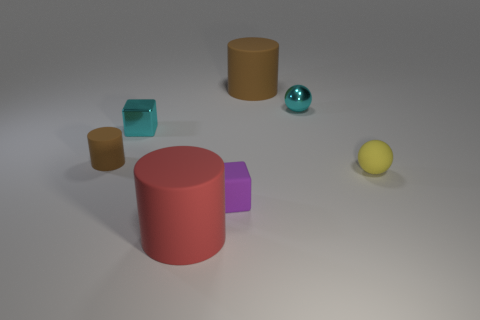How would you categorize the arrangement of objects in the image? The objects are arranged in a somewhat scattered fashion across a flat surface but maintain a sense of balance and simplicity. It appears to be a deliberate composition, possibly for an exercise in perspective, lighting, or color study. 